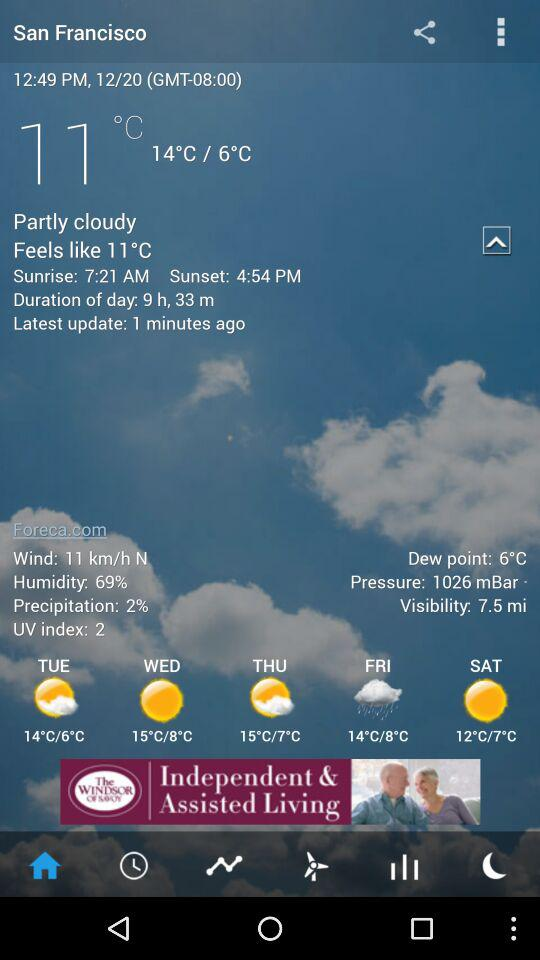What is the humidity? The humidity is 69%. 